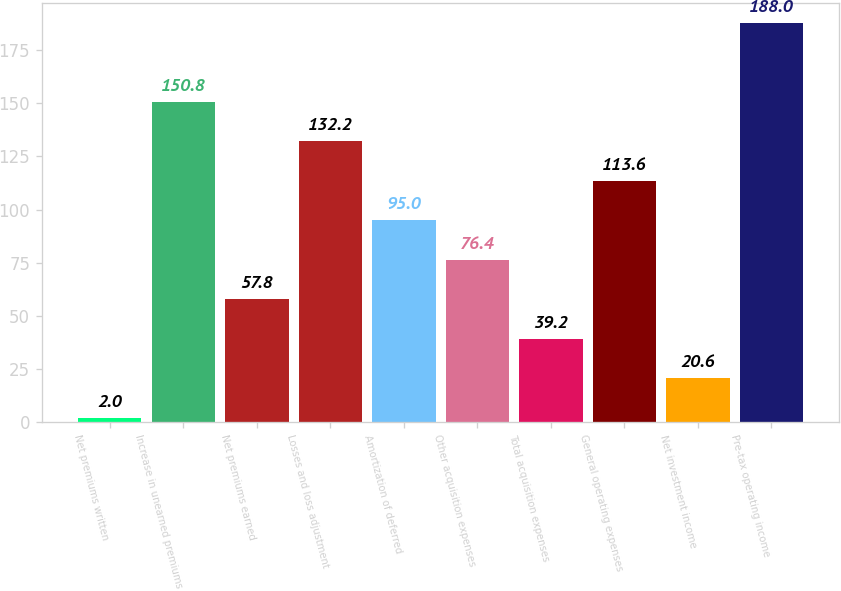<chart> <loc_0><loc_0><loc_500><loc_500><bar_chart><fcel>Net premiums written<fcel>Increase in unearned premiums<fcel>Net premiums earned<fcel>Losses and loss adjustment<fcel>Amortization of deferred<fcel>Other acquisition expenses<fcel>Total acquisition expenses<fcel>General operating expenses<fcel>Net investment income<fcel>Pre-tax operating income<nl><fcel>2<fcel>150.8<fcel>57.8<fcel>132.2<fcel>95<fcel>76.4<fcel>39.2<fcel>113.6<fcel>20.6<fcel>188<nl></chart> 